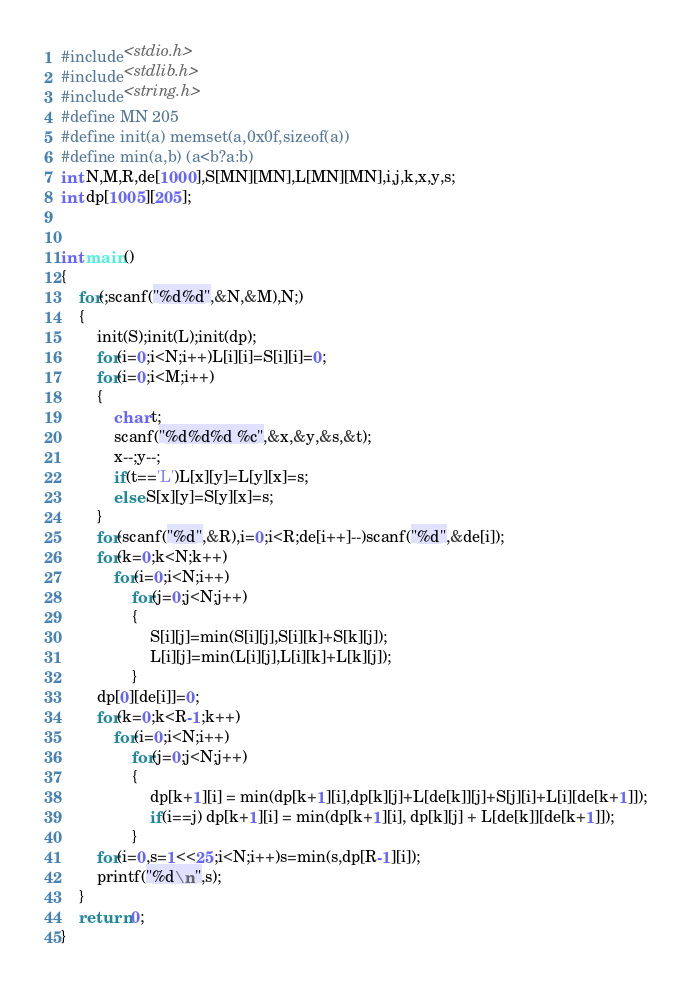Convert code to text. <code><loc_0><loc_0><loc_500><loc_500><_C_>#include<stdio.h>
#include<stdlib.h>
#include<string.h>
#define MN 205
#define init(a) memset(a,0x0f,sizeof(a))
#define min(a,b) (a<b?a:b)
int N,M,R,de[1000],S[MN][MN],L[MN][MN],i,j,k,x,y,s;
int dp[1005][205];


int main()
{
	for(;scanf("%d%d",&N,&M),N;)
	{
		init(S);init(L);init(dp);
		for(i=0;i<N;i++)L[i][i]=S[i][i]=0;
		for(i=0;i<M;i++)
		{
			char t;
			scanf("%d%d%d %c",&x,&y,&s,&t);
			x--;y--;
			if(t=='L')L[x][y]=L[y][x]=s;
			else S[x][y]=S[y][x]=s;
		}
		for(scanf("%d",&R),i=0;i<R;de[i++]--)scanf("%d",&de[i]);
		for(k=0;k<N;k++)
			for(i=0;i<N;i++)
				for(j=0;j<N;j++)
				{
					S[i][j]=min(S[i][j],S[i][k]+S[k][j]);
					L[i][j]=min(L[i][j],L[i][k]+L[k][j]);
				}
		dp[0][de[i]]=0;
		for(k=0;k<R-1;k++)
			for(i=0;i<N;i++)
				for(j=0;j<N;j++)
				{
					dp[k+1][i] = min(dp[k+1][i],dp[k][j]+L[de[k]][j]+S[j][i]+L[i][de[k+1]]);
					if(i==j) dp[k+1][i] = min(dp[k+1][i], dp[k][j] + L[de[k]][de[k+1]]);
				}
		for(i=0,s=1<<25;i<N;i++)s=min(s,dp[R-1][i]);
		printf("%d\n",s);
	}
	return 0;
}</code> 